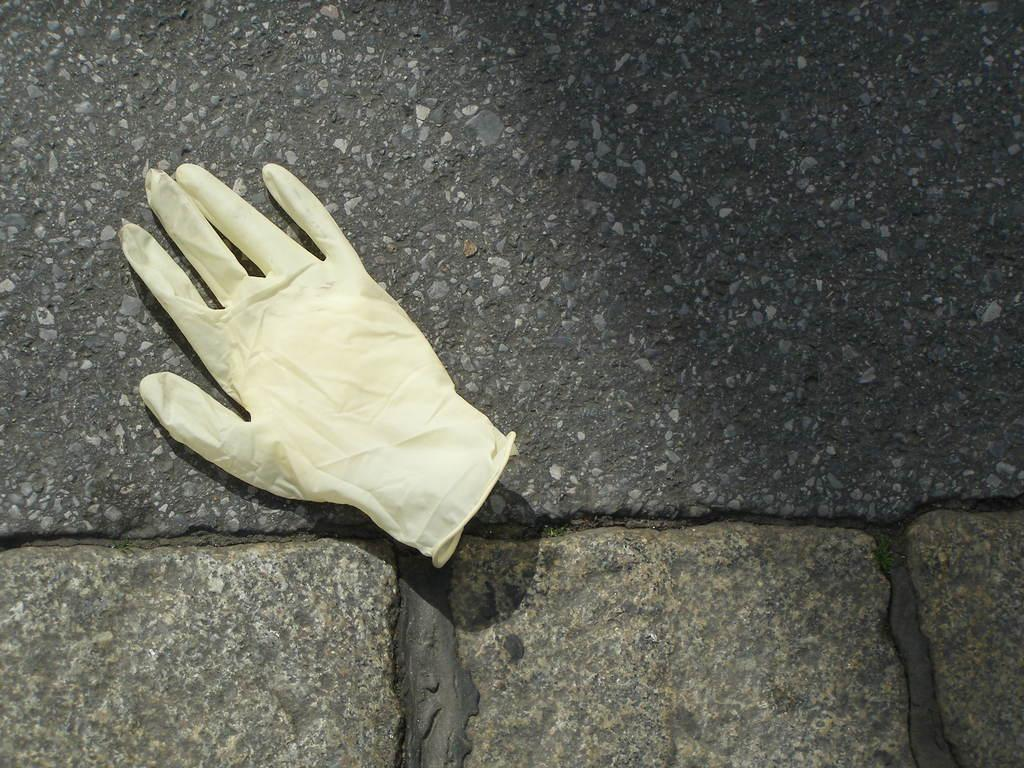What object is placed on a surface in the image? There is a glove on a surface in the image. How does the glove show respect to the account on the day in the image? The image does not depict any account or day, nor does it show the glove interacting with any account or day. The glove is simply placed on a surface. 